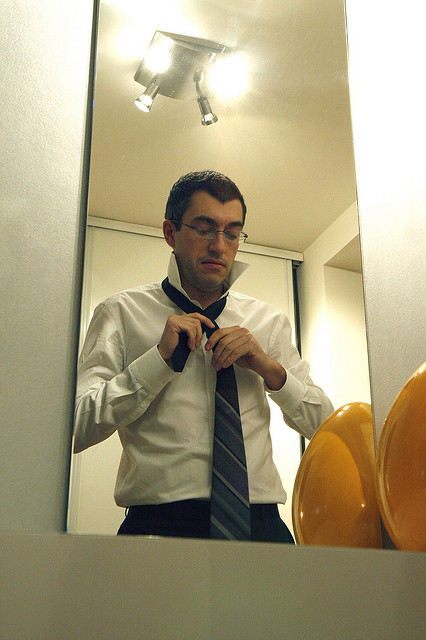If there were an umbrella in the image, where would you expect it to be? While there isn't an umbrella in the image, if it were present, it would likely be positioned near an entryway or in a corner, possibly tucked away in a stand. Commonly, umbrellas are stored in areas where they can be easily accessed when needed, especially in indoor settings like this. 